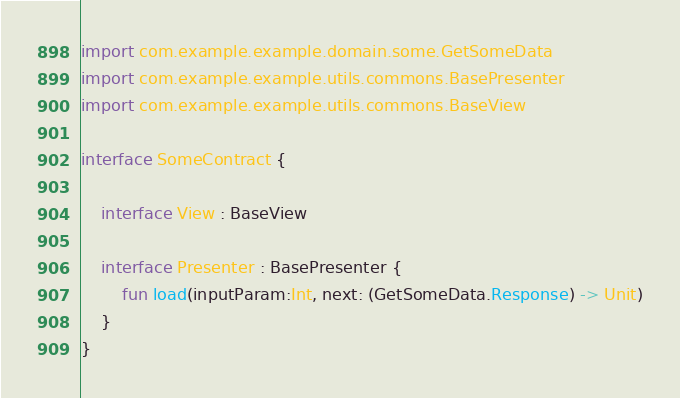<code> <loc_0><loc_0><loc_500><loc_500><_Kotlin_>import com.example.example.domain.some.GetSomeData
import com.example.example.utils.commons.BasePresenter
import com.example.example.utils.commons.BaseView

interface SomeContract {

    interface View : BaseView

    interface Presenter : BasePresenter {
        fun load(inputParam:Int, next: (GetSomeData.Response) -> Unit)
    }
}
</code> 